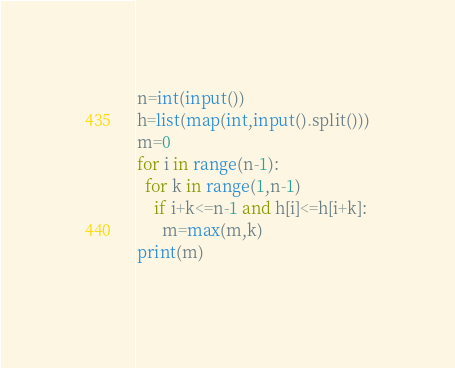<code> <loc_0><loc_0><loc_500><loc_500><_Python_>n=int(input())
h=list(map(int,input().split()))
m=0
for i in range(n-1):
  for k in range(1,n-1)
    if i+k<=n-1 and h[i]<=h[i+k]:
      m=max(m,k)
print(m)
     </code> 